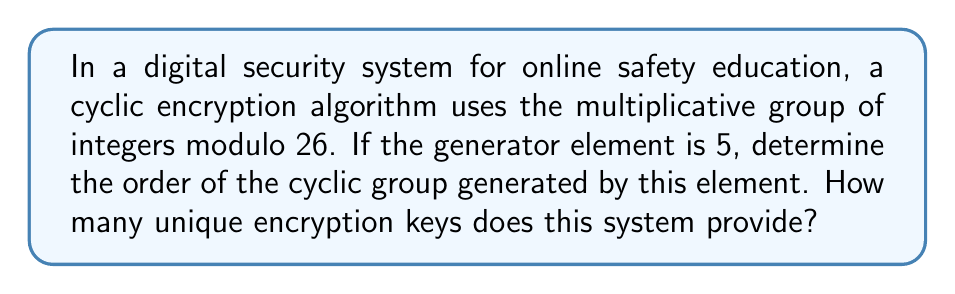Teach me how to tackle this problem. To solve this problem, we need to follow these steps:

1) First, we need to understand what the order of a cyclic group means. The order of a cyclic group generated by an element $a$ is the smallest positive integer $n$ such that $a^n \equiv 1 \pmod{m}$, where $m$ is the modulus.

2) In this case, we're working in the multiplicative group of integers modulo 26, and our generator element is 5.

3) Let's compute the powers of 5 modulo 26 until we get back to 1:

   $5^1 \equiv 5 \pmod{26}$
   $5^2 \equiv 25 \pmod{26}$
   $5^3 \equiv 21 \pmod{26}$
   $5^4 \equiv 1 \pmod{26}$

4) We see that $5^4 \equiv 1 \pmod{26}$, and this is the smallest positive power that gives us 1.

5) Therefore, the order of the cyclic group generated by 5 is 4.

6) This means that the system provides 4 unique encryption keys, corresponding to the elements of the cyclic subgroup: $\{5^1, 5^2, 5^3, 5^4\} \equiv \{5, 25, 21, 1\} \pmod{26}$.

This result is particularly relevant for online safety education as it demonstrates how even a simple cyclic group can generate multiple unique keys, which is a fundamental concept in encryption and digital security.
Answer: The order of the cyclic group generated by 5 in the multiplicative group of integers modulo 26 is 4. The system provides 4 unique encryption keys. 